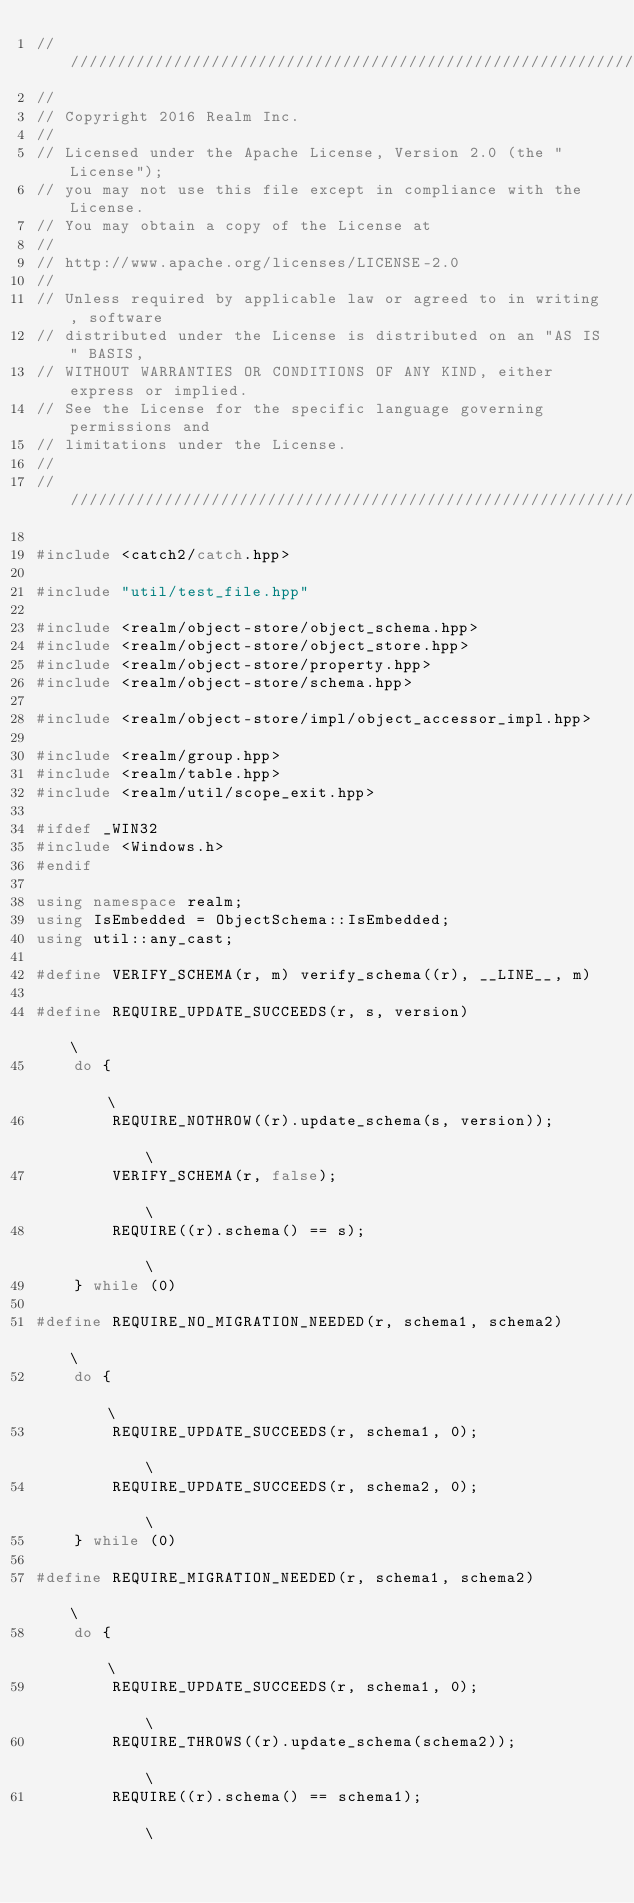<code> <loc_0><loc_0><loc_500><loc_500><_C++_>////////////////////////////////////////////////////////////////////////////
//
// Copyright 2016 Realm Inc.
//
// Licensed under the Apache License, Version 2.0 (the "License");
// you may not use this file except in compliance with the License.
// You may obtain a copy of the License at
//
// http://www.apache.org/licenses/LICENSE-2.0
//
// Unless required by applicable law or agreed to in writing, software
// distributed under the License is distributed on an "AS IS" BASIS,
// WITHOUT WARRANTIES OR CONDITIONS OF ANY KIND, either express or implied.
// See the License for the specific language governing permissions and
// limitations under the License.
//
////////////////////////////////////////////////////////////////////////////

#include <catch2/catch.hpp>

#include "util/test_file.hpp"

#include <realm/object-store/object_schema.hpp>
#include <realm/object-store/object_store.hpp>
#include <realm/object-store/property.hpp>
#include <realm/object-store/schema.hpp>

#include <realm/object-store/impl/object_accessor_impl.hpp>

#include <realm/group.hpp>
#include <realm/table.hpp>
#include <realm/util/scope_exit.hpp>

#ifdef _WIN32
#include <Windows.h>
#endif

using namespace realm;
using IsEmbedded = ObjectSchema::IsEmbedded;
using util::any_cast;

#define VERIFY_SCHEMA(r, m) verify_schema((r), __LINE__, m)

#define REQUIRE_UPDATE_SUCCEEDS(r, s, version)                                                                       \
    do {                                                                                                             \
        REQUIRE_NOTHROW((r).update_schema(s, version));                                                              \
        VERIFY_SCHEMA(r, false);                                                                                     \
        REQUIRE((r).schema() == s);                                                                                  \
    } while (0)

#define REQUIRE_NO_MIGRATION_NEEDED(r, schema1, schema2)                                                             \
    do {                                                                                                             \
        REQUIRE_UPDATE_SUCCEEDS(r, schema1, 0);                                                                      \
        REQUIRE_UPDATE_SUCCEEDS(r, schema2, 0);                                                                      \
    } while (0)

#define REQUIRE_MIGRATION_NEEDED(r, schema1, schema2)                                                                \
    do {                                                                                                             \
        REQUIRE_UPDATE_SUCCEEDS(r, schema1, 0);                                                                      \
        REQUIRE_THROWS((r).update_schema(schema2));                                                                  \
        REQUIRE((r).schema() == schema1);                                                                            \</code> 